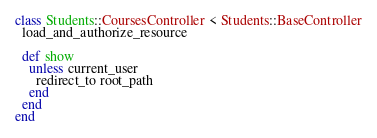<code> <loc_0><loc_0><loc_500><loc_500><_Ruby_>class Students::CoursesController < Students::BaseController
  load_and_authorize_resource

  def show
    unless current_user
      redirect_to root_path
    end
  end
end
</code> 